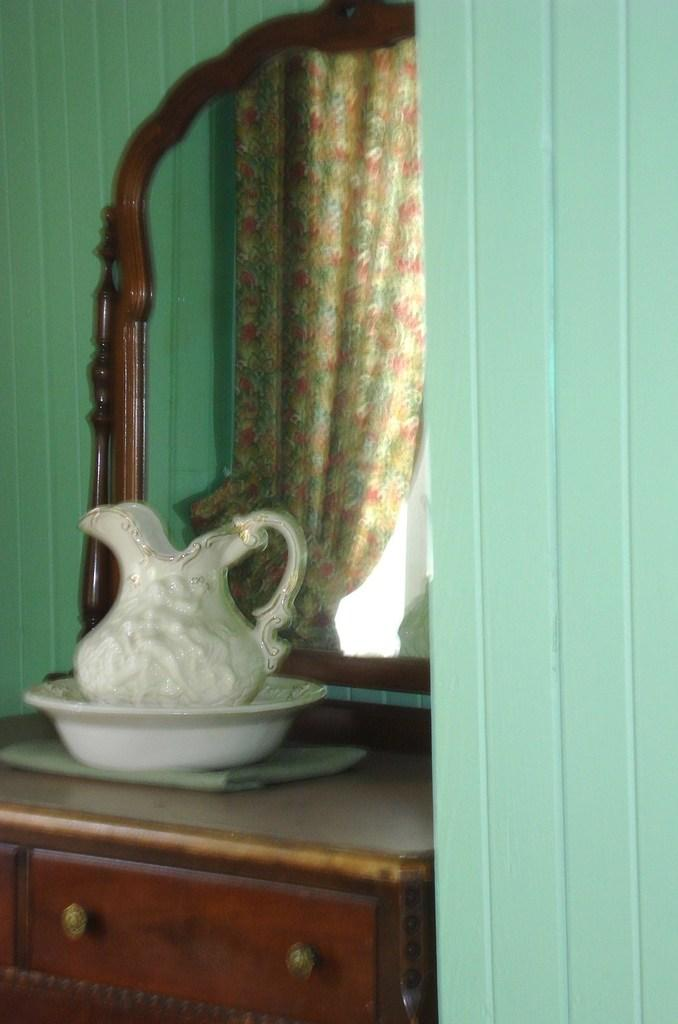What is placed inside the bowl in the image? There is a jar in a bowl in the image. Where is the jar and bowl located? The jar and bowl are placed on a cupboard. What can be seen in the image besides the jar and bowl? There is a mirror in the image. What part of the room can be seen in the image? The walls are visible in the image. What is reflected in the mirror? There is a curtain visible in the mirror. What is the purpose of the wax in the image? There is no wax present in the image, so it is not possible to determine its purpose. 